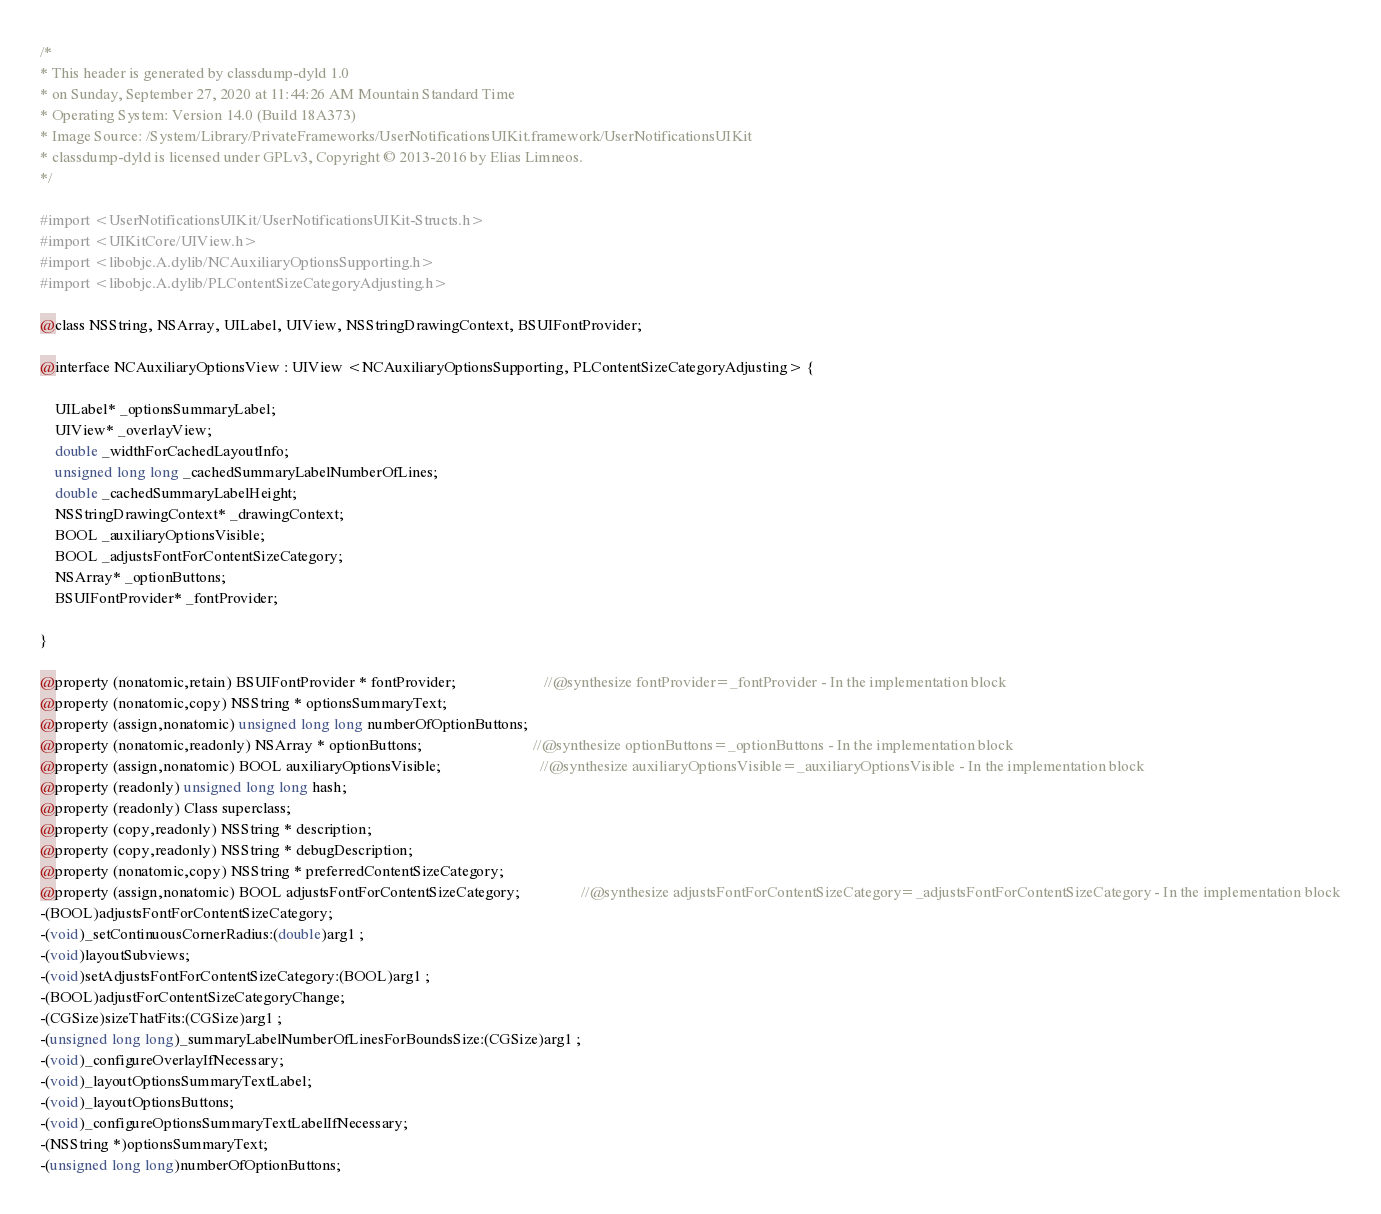<code> <loc_0><loc_0><loc_500><loc_500><_C_>/*
* This header is generated by classdump-dyld 1.0
* on Sunday, September 27, 2020 at 11:44:26 AM Mountain Standard Time
* Operating System: Version 14.0 (Build 18A373)
* Image Source: /System/Library/PrivateFrameworks/UserNotificationsUIKit.framework/UserNotificationsUIKit
* classdump-dyld is licensed under GPLv3, Copyright © 2013-2016 by Elias Limneos.
*/

#import <UserNotificationsUIKit/UserNotificationsUIKit-Structs.h>
#import <UIKitCore/UIView.h>
#import <libobjc.A.dylib/NCAuxiliaryOptionsSupporting.h>
#import <libobjc.A.dylib/PLContentSizeCategoryAdjusting.h>

@class NSString, NSArray, UILabel, UIView, NSStringDrawingContext, BSUIFontProvider;

@interface NCAuxiliaryOptionsView : UIView <NCAuxiliaryOptionsSupporting, PLContentSizeCategoryAdjusting> {

	UILabel* _optionsSummaryLabel;
	UIView* _overlayView;
	double _widthForCachedLayoutInfo;
	unsigned long long _cachedSummaryLabelNumberOfLines;
	double _cachedSummaryLabelHeight;
	NSStringDrawingContext* _drawingContext;
	BOOL _auxiliaryOptionsVisible;
	BOOL _adjustsFontForContentSizeCategory;
	NSArray* _optionButtons;
	BSUIFontProvider* _fontProvider;

}

@property (nonatomic,retain) BSUIFontProvider * fontProvider;                       //@synthesize fontProvider=_fontProvider - In the implementation block
@property (nonatomic,copy) NSString * optionsSummaryText; 
@property (assign,nonatomic) unsigned long long numberOfOptionButtons; 
@property (nonatomic,readonly) NSArray * optionButtons;                             //@synthesize optionButtons=_optionButtons - In the implementation block
@property (assign,nonatomic) BOOL auxiliaryOptionsVisible;                          //@synthesize auxiliaryOptionsVisible=_auxiliaryOptionsVisible - In the implementation block
@property (readonly) unsigned long long hash; 
@property (readonly) Class superclass; 
@property (copy,readonly) NSString * description; 
@property (copy,readonly) NSString * debugDescription; 
@property (nonatomic,copy) NSString * preferredContentSizeCategory; 
@property (assign,nonatomic) BOOL adjustsFontForContentSizeCategory;                //@synthesize adjustsFontForContentSizeCategory=_adjustsFontForContentSizeCategory - In the implementation block
-(BOOL)adjustsFontForContentSizeCategory;
-(void)_setContinuousCornerRadius:(double)arg1 ;
-(void)layoutSubviews;
-(void)setAdjustsFontForContentSizeCategory:(BOOL)arg1 ;
-(BOOL)adjustForContentSizeCategoryChange;
-(CGSize)sizeThatFits:(CGSize)arg1 ;
-(unsigned long long)_summaryLabelNumberOfLinesForBoundsSize:(CGSize)arg1 ;
-(void)_configureOverlayIfNecessary;
-(void)_layoutOptionsSummaryTextLabel;
-(void)_layoutOptionsButtons;
-(void)_configureOptionsSummaryTextLabelIfNecessary;
-(NSString *)optionsSummaryText;
-(unsigned long long)numberOfOptionButtons;</code> 